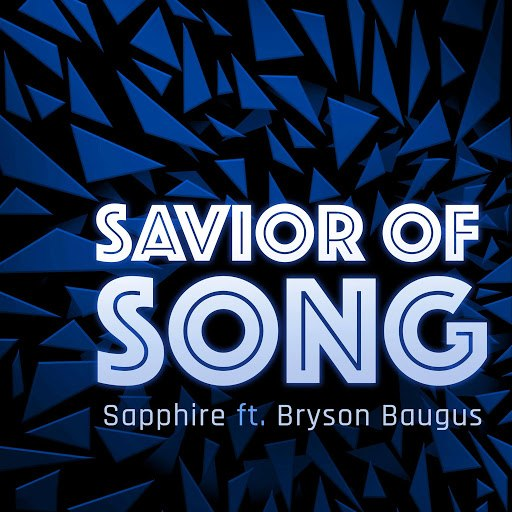What does the stylistic choice of the shattered glass background suggest about the theme or genre of the "SAVIOR OF SONG"? The use of shattered glass in the background of 'SAVIOR OF SONG' visually communicates a theme of dramatic disruption and profound transformation. This choice suggests a narrative of breaking away from the old to reveal something new and powerful, a common motif in genres like rock or electronic music known for their bold and intense sounds. Additionally, this imagery might also hint at emotional depth, reflective of overcoming challenges or triumphing over adversity, themes often explored in powerful anthemic music. Therefore, both visually and thematically, the artwork complements the energy and emotion expected in such musical pieces. 